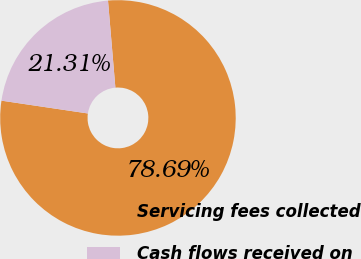Convert chart. <chart><loc_0><loc_0><loc_500><loc_500><pie_chart><fcel>Servicing fees collected<fcel>Cash flows received on<nl><fcel>78.69%<fcel>21.31%<nl></chart> 